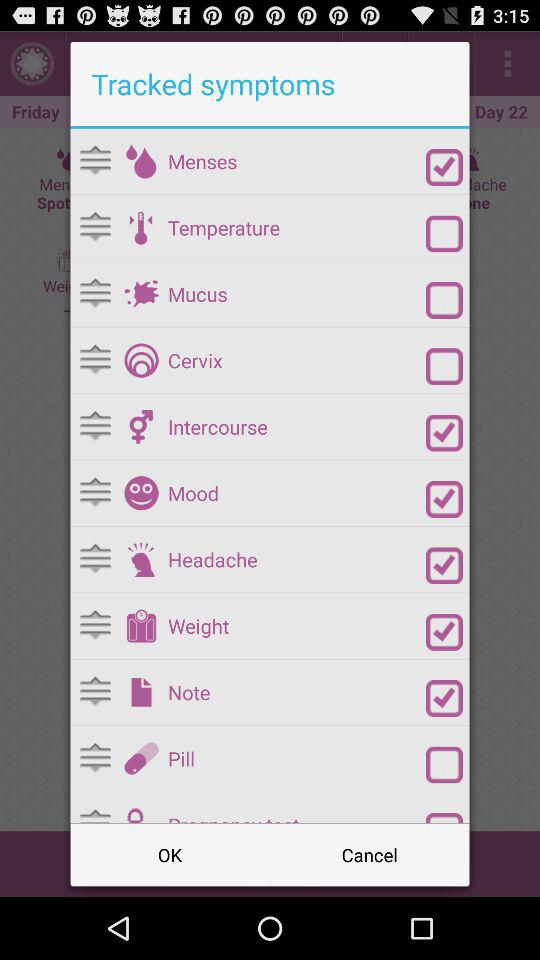How many of the symptoms are checked?
Answer the question using a single word or phrase. 6 